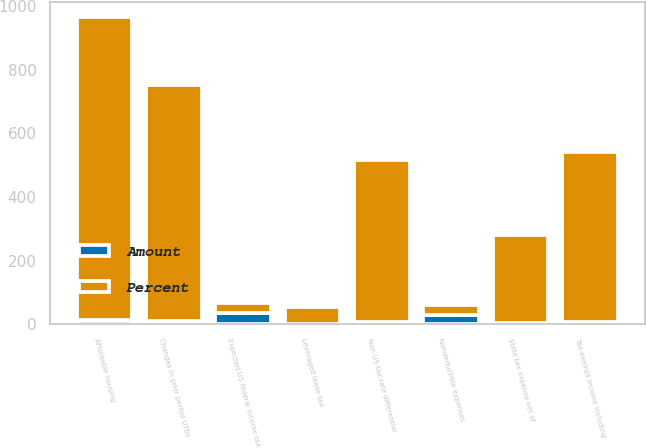Convert chart. <chart><loc_0><loc_0><loc_500><loc_500><stacked_bar_chart><ecel><fcel>Expected US federal income tax<fcel>State tax expense net of<fcel>Affordable housing<fcel>Changes in prior period UTBs<fcel>Tax-exempt income including<fcel>Non-US tax rate differential<fcel>Nondeductible expenses<fcel>Leveraged lease tax<nl><fcel>Percent<fcel>31.95<fcel>276<fcel>950<fcel>741<fcel>533<fcel>507<fcel>31.95<fcel>53<nl><fcel>Amount<fcel>35<fcel>4<fcel>13.8<fcel>10.8<fcel>7.8<fcel>7.4<fcel>28.9<fcel>0.8<nl></chart> 